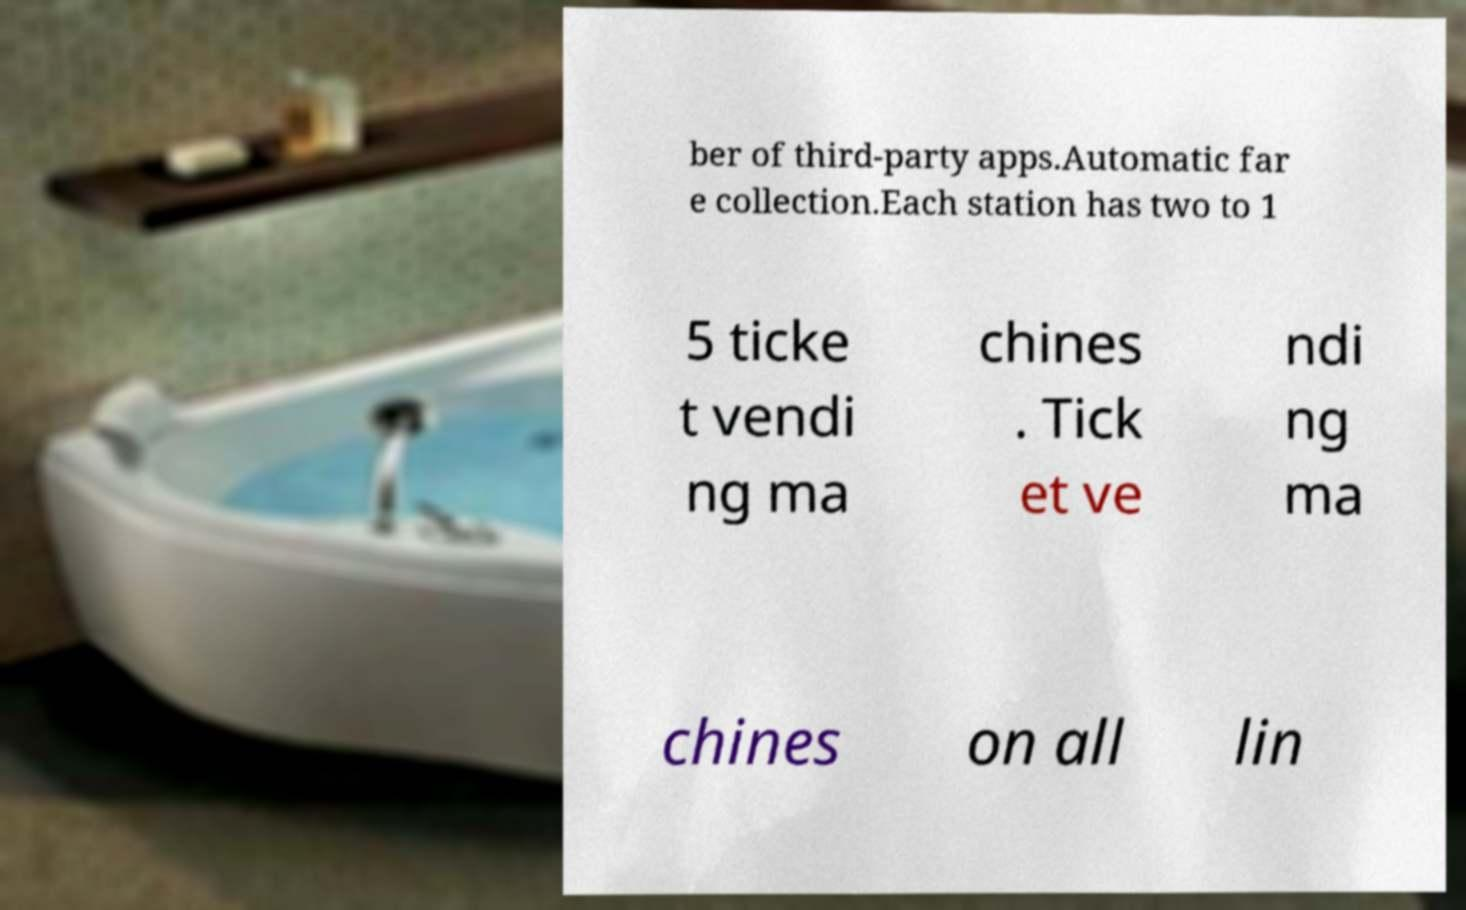Please read and relay the text visible in this image. What does it say? ber of third-party apps.Automatic far e collection.Each station has two to 1 5 ticke t vendi ng ma chines . Tick et ve ndi ng ma chines on all lin 